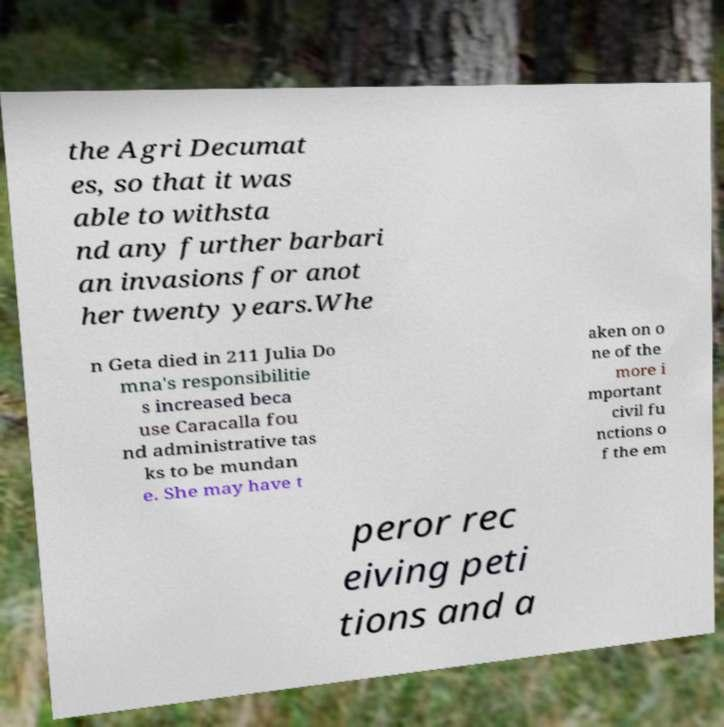There's text embedded in this image that I need extracted. Can you transcribe it verbatim? the Agri Decumat es, so that it was able to withsta nd any further barbari an invasions for anot her twenty years.Whe n Geta died in 211 Julia Do mna's responsibilitie s increased beca use Caracalla fou nd administrative tas ks to be mundan e. She may have t aken on o ne of the more i mportant civil fu nctions o f the em peror rec eiving peti tions and a 